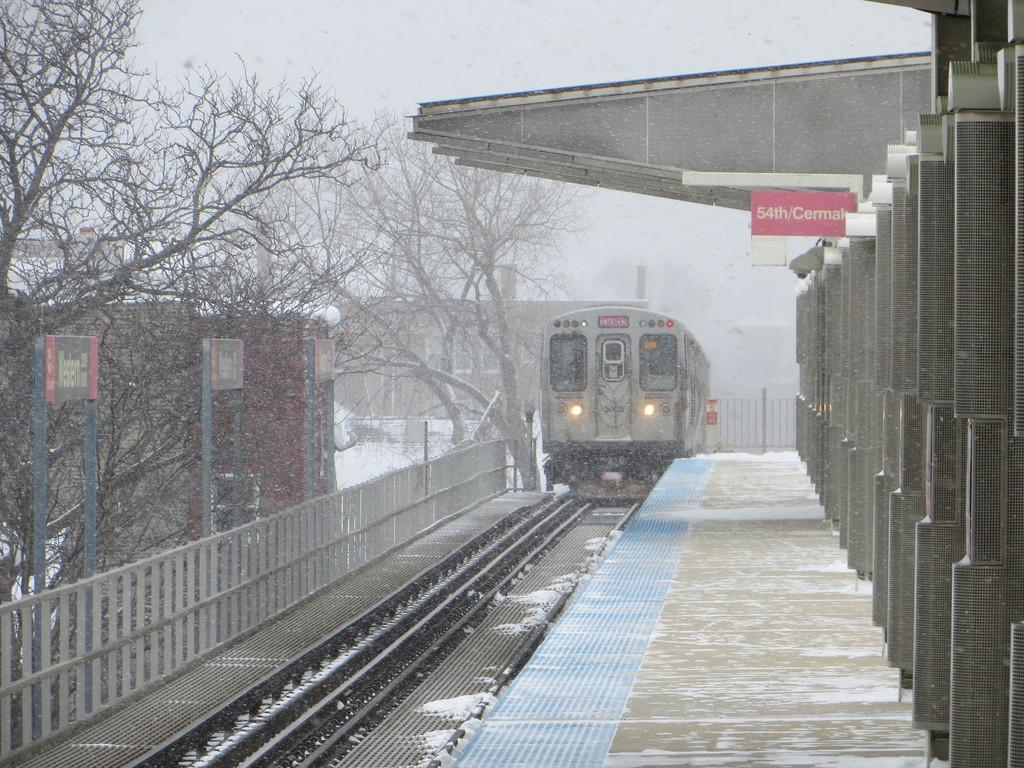<image>
Summarize the visual content of the image. A gray train is pullingn up to 54th/cermal station in the snow. 